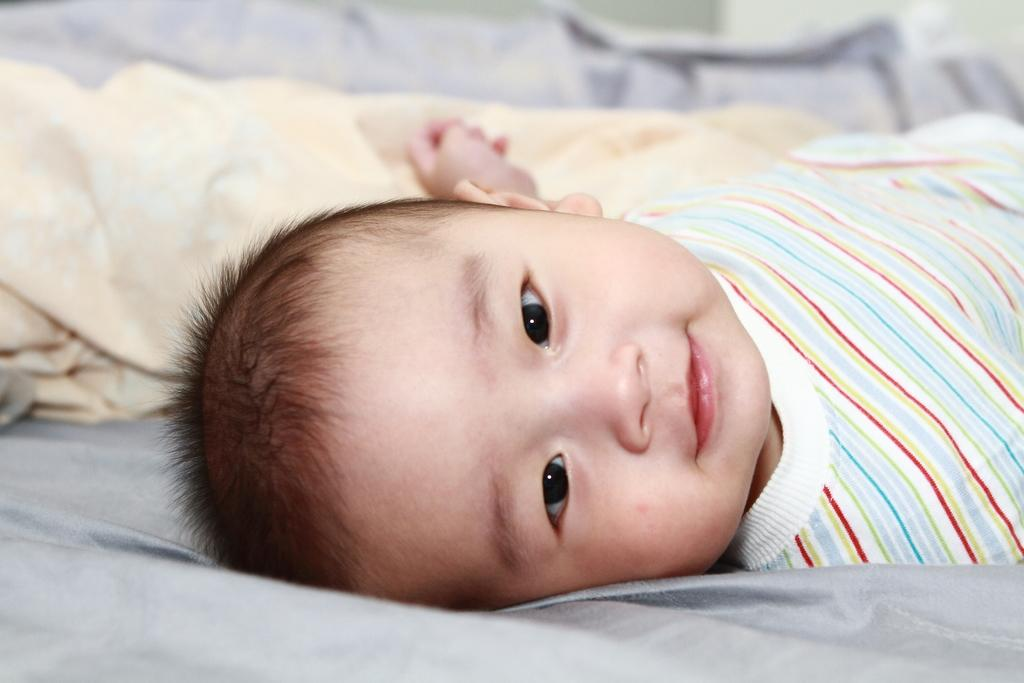What is the position of the kid in the image? The kid is laying in the image. What can be seen in the background of the image? There is a blanket visible in the background of the image. What type of shock can be seen happening in the scene in the image? There is no shock or scene happening in the image; it simply shows a kid laying with a blanket in the background. 